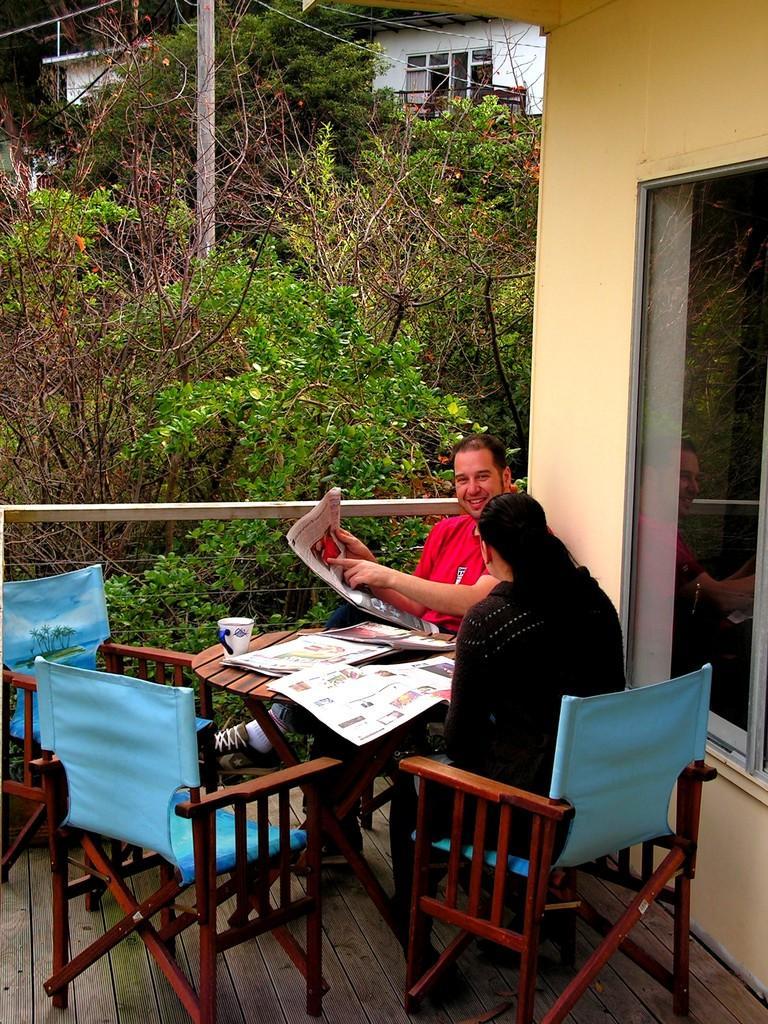How would you summarize this image in a sentence or two? in the center we can see two persons were sitting on the chair around the table. On table we can see newspaper,coffee cup. And coming to background we can see building,window,trees. 